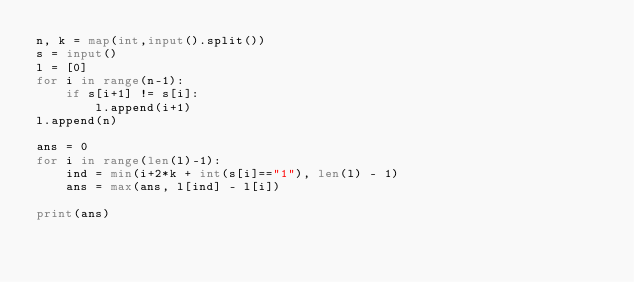<code> <loc_0><loc_0><loc_500><loc_500><_Python_>n, k = map(int,input().split())
s = input()
l = [0]
for i in range(n-1):
    if s[i+1] != s[i]:
        l.append(i+1)
l.append(n)

ans = 0
for i in range(len(l)-1):
    ind = min(i+2*k + int(s[i]=="1"), len(l) - 1)
    ans = max(ans, l[ind] - l[i])

print(ans)</code> 